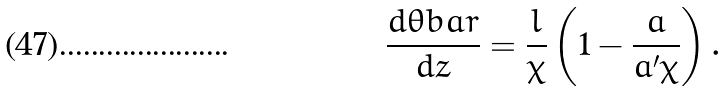<formula> <loc_0><loc_0><loc_500><loc_500>\frac { d \theta b a r } { d z } = \frac { l } { \chi } \left ( 1 - \frac { a } { a ^ { \prime } \chi } \right ) .</formula> 